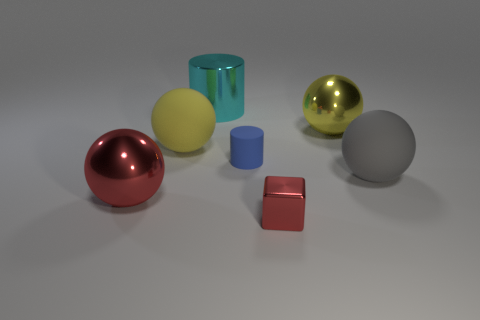The ball that is the same color as the cube is what size?
Ensure brevity in your answer.  Large. The object that is the same size as the red cube is what color?
Give a very brief answer. Blue. Does the tiny cylinder have the same color as the big shiny ball right of the cyan shiny object?
Provide a succinct answer. No. The big shiny cylinder has what color?
Offer a very short reply. Cyan. What material is the ball in front of the big gray ball?
Your answer should be compact. Metal. What is the size of the yellow metallic thing that is the same shape as the big red thing?
Your answer should be compact. Large. Is the number of large yellow matte spheres in front of the blue cylinder less than the number of small cyan matte things?
Your response must be concise. No. Are there any large blue blocks?
Provide a succinct answer. No. There is a large metal thing that is the same shape as the small blue object; what color is it?
Offer a terse response. Cyan. Do the big metal thing that is in front of the matte cylinder and the metallic cube have the same color?
Ensure brevity in your answer.  Yes. 